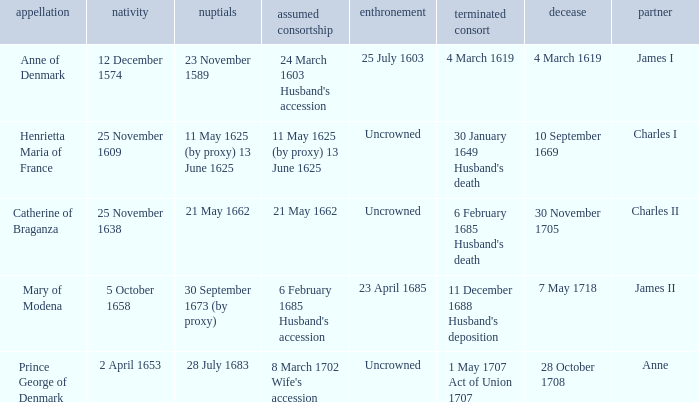On what date did James II take a consort? 6 February 1685 Husband's accession. 